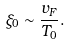Convert formula to latex. <formula><loc_0><loc_0><loc_500><loc_500>\xi _ { 0 } \sim \frac { v _ { F } } { T _ { 0 } } .</formula> 